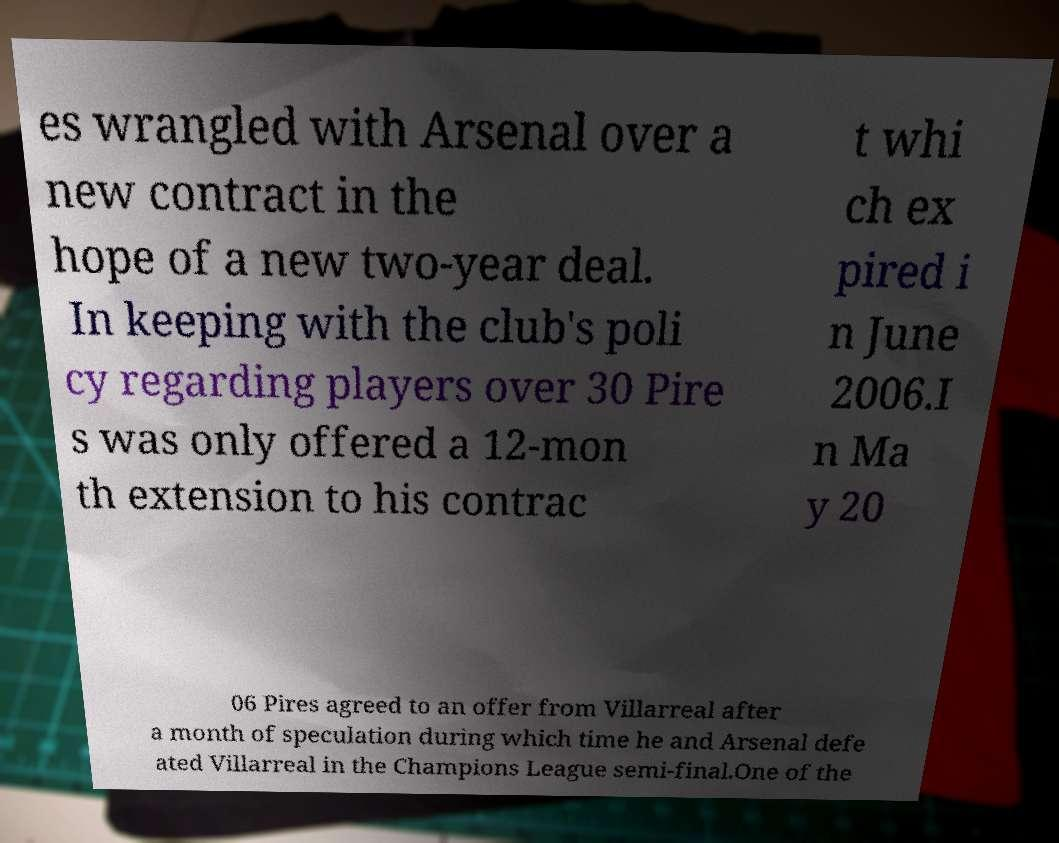I need the written content from this picture converted into text. Can you do that? es wrangled with Arsenal over a new contract in the hope of a new two-year deal. In keeping with the club's poli cy regarding players over 30 Pire s was only offered a 12-mon th extension to his contrac t whi ch ex pired i n June 2006.I n Ma y 20 06 Pires agreed to an offer from Villarreal after a month of speculation during which time he and Arsenal defe ated Villarreal in the Champions League semi-final.One of the 